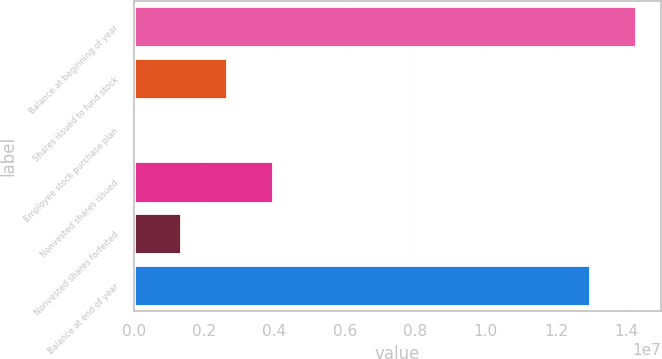Convert chart. <chart><loc_0><loc_0><loc_500><loc_500><bar_chart><fcel>Balance at beginning of year<fcel>Shares issued to fund stock<fcel>Employee stock purchase plan<fcel>Nonvested shares issued<fcel>Nonvested shares forfeited<fcel>Balance at end of year<nl><fcel>1.42688e+07<fcel>2.65131e+06<fcel>33402<fcel>3.96027e+06<fcel>1.34236e+06<fcel>1.29599e+07<nl></chart> 